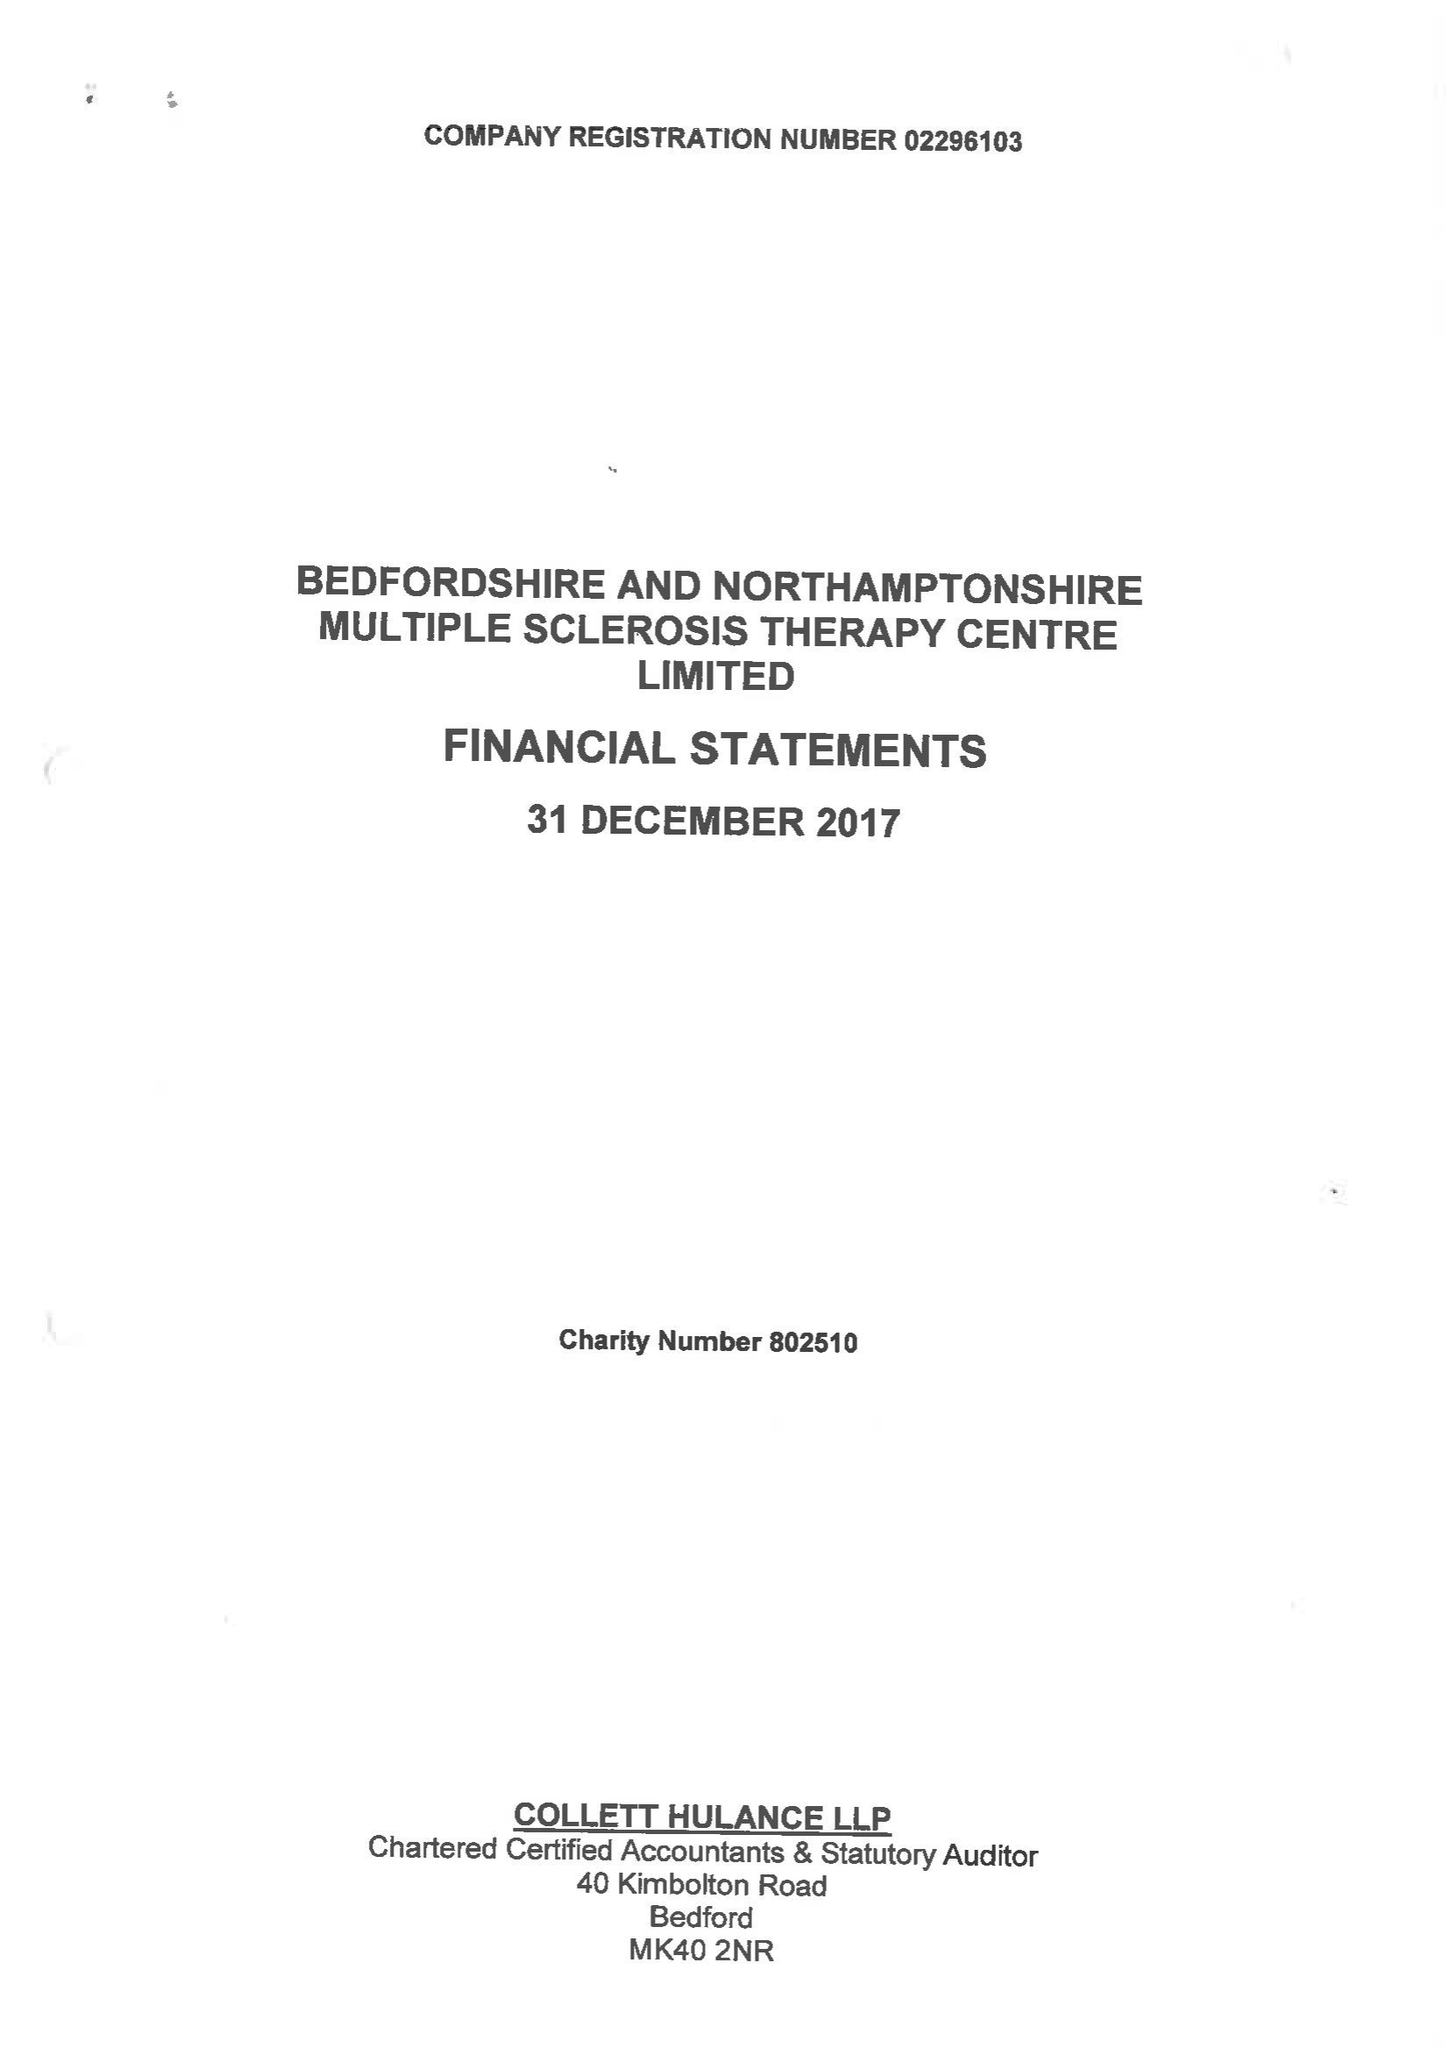What is the value for the address__post_town?
Answer the question using a single word or phrase. BEDFORD 